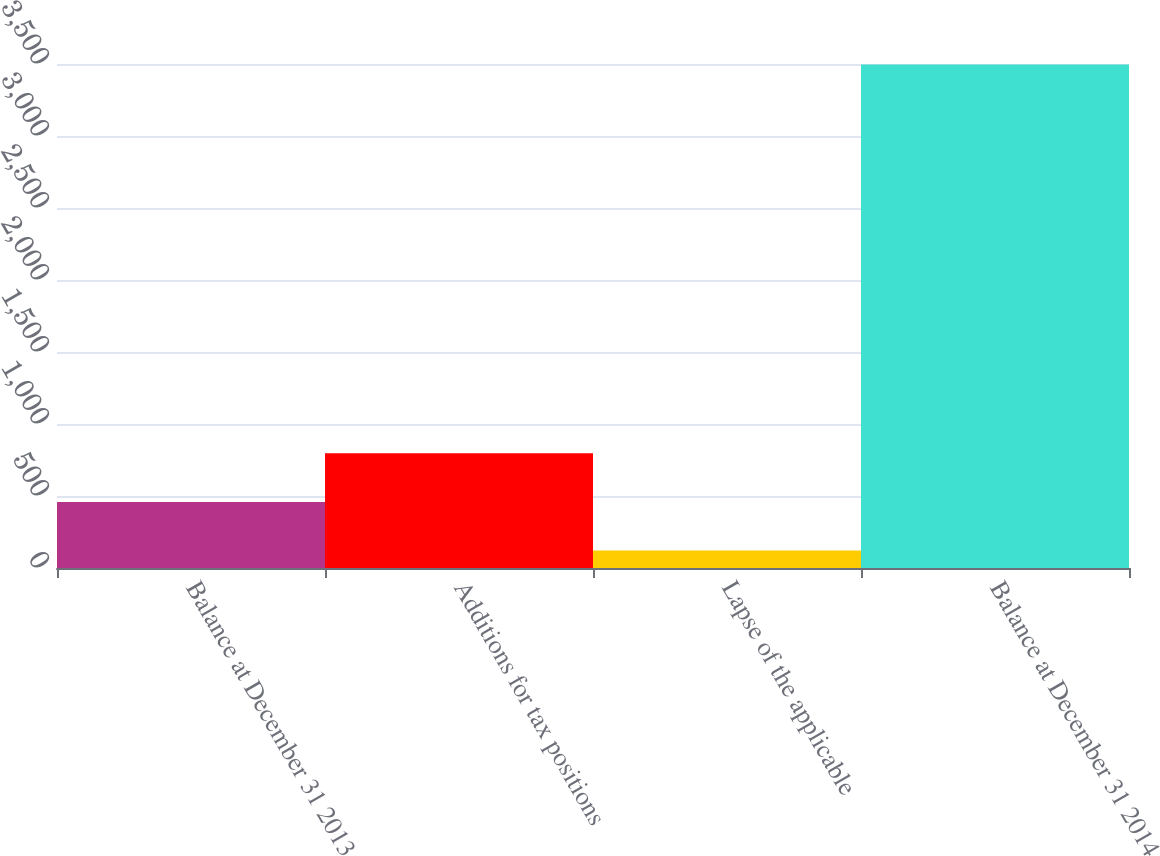Convert chart to OTSL. <chart><loc_0><loc_0><loc_500><loc_500><bar_chart><fcel>Balance at December 31 2013<fcel>Additions for tax positions<fcel>Lapse of the applicable<fcel>Balance at December 31 2014<nl><fcel>458.6<fcel>796.2<fcel>121<fcel>3497<nl></chart> 